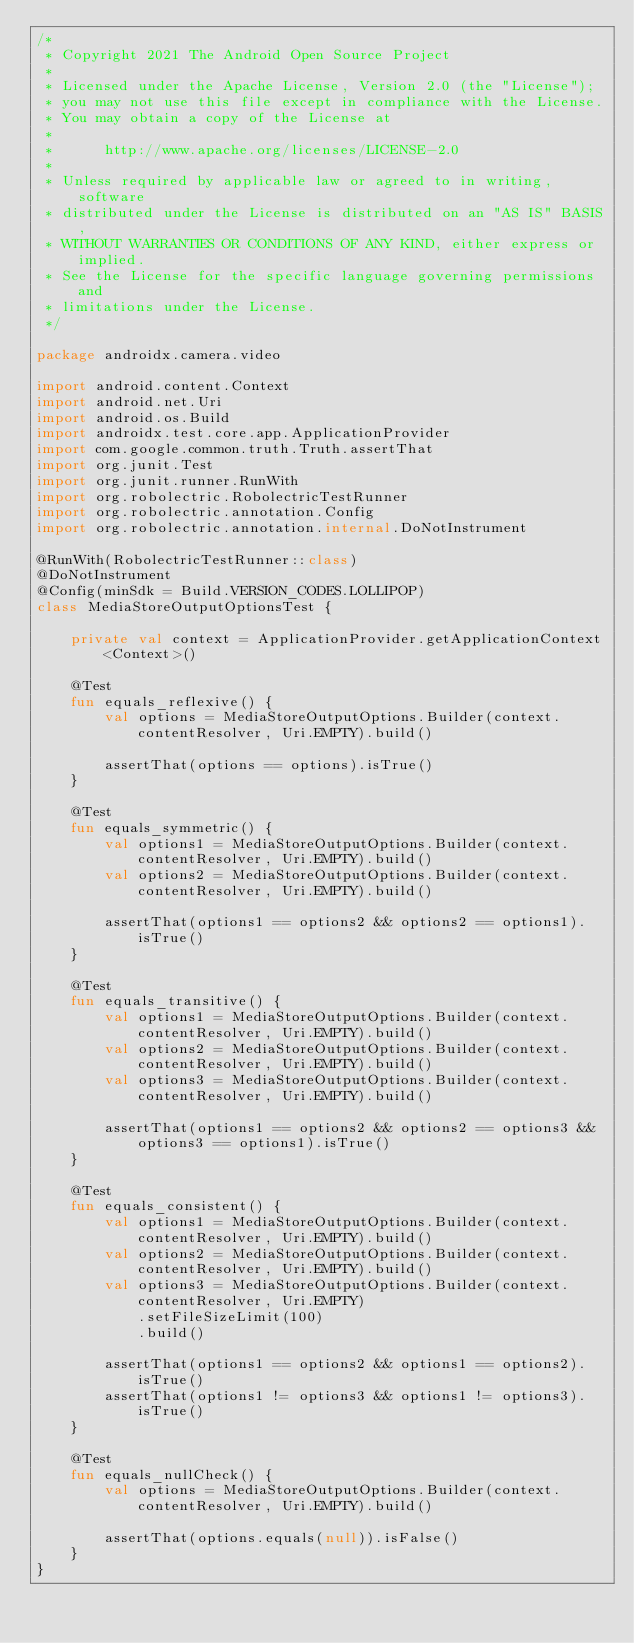<code> <loc_0><loc_0><loc_500><loc_500><_Kotlin_>/*
 * Copyright 2021 The Android Open Source Project
 *
 * Licensed under the Apache License, Version 2.0 (the "License");
 * you may not use this file except in compliance with the License.
 * You may obtain a copy of the License at
 *
 *      http://www.apache.org/licenses/LICENSE-2.0
 *
 * Unless required by applicable law or agreed to in writing, software
 * distributed under the License is distributed on an "AS IS" BASIS,
 * WITHOUT WARRANTIES OR CONDITIONS OF ANY KIND, either express or implied.
 * See the License for the specific language governing permissions and
 * limitations under the License.
 */

package androidx.camera.video

import android.content.Context
import android.net.Uri
import android.os.Build
import androidx.test.core.app.ApplicationProvider
import com.google.common.truth.Truth.assertThat
import org.junit.Test
import org.junit.runner.RunWith
import org.robolectric.RobolectricTestRunner
import org.robolectric.annotation.Config
import org.robolectric.annotation.internal.DoNotInstrument

@RunWith(RobolectricTestRunner::class)
@DoNotInstrument
@Config(minSdk = Build.VERSION_CODES.LOLLIPOP)
class MediaStoreOutputOptionsTest {

    private val context = ApplicationProvider.getApplicationContext<Context>()

    @Test
    fun equals_reflexive() {
        val options = MediaStoreOutputOptions.Builder(context.contentResolver, Uri.EMPTY).build()

        assertThat(options == options).isTrue()
    }

    @Test
    fun equals_symmetric() {
        val options1 = MediaStoreOutputOptions.Builder(context.contentResolver, Uri.EMPTY).build()
        val options2 = MediaStoreOutputOptions.Builder(context.contentResolver, Uri.EMPTY).build()

        assertThat(options1 == options2 && options2 == options1).isTrue()
    }

    @Test
    fun equals_transitive() {
        val options1 = MediaStoreOutputOptions.Builder(context.contentResolver, Uri.EMPTY).build()
        val options2 = MediaStoreOutputOptions.Builder(context.contentResolver, Uri.EMPTY).build()
        val options3 = MediaStoreOutputOptions.Builder(context.contentResolver, Uri.EMPTY).build()

        assertThat(options1 == options2 && options2 == options3 && options3 == options1).isTrue()
    }

    @Test
    fun equals_consistent() {
        val options1 = MediaStoreOutputOptions.Builder(context.contentResolver, Uri.EMPTY).build()
        val options2 = MediaStoreOutputOptions.Builder(context.contentResolver, Uri.EMPTY).build()
        val options3 = MediaStoreOutputOptions.Builder(context.contentResolver, Uri.EMPTY)
            .setFileSizeLimit(100)
            .build()

        assertThat(options1 == options2 && options1 == options2).isTrue()
        assertThat(options1 != options3 && options1 != options3).isTrue()
    }

    @Test
    fun equals_nullCheck() {
        val options = MediaStoreOutputOptions.Builder(context.contentResolver, Uri.EMPTY).build()

        assertThat(options.equals(null)).isFalse()
    }
}
</code> 